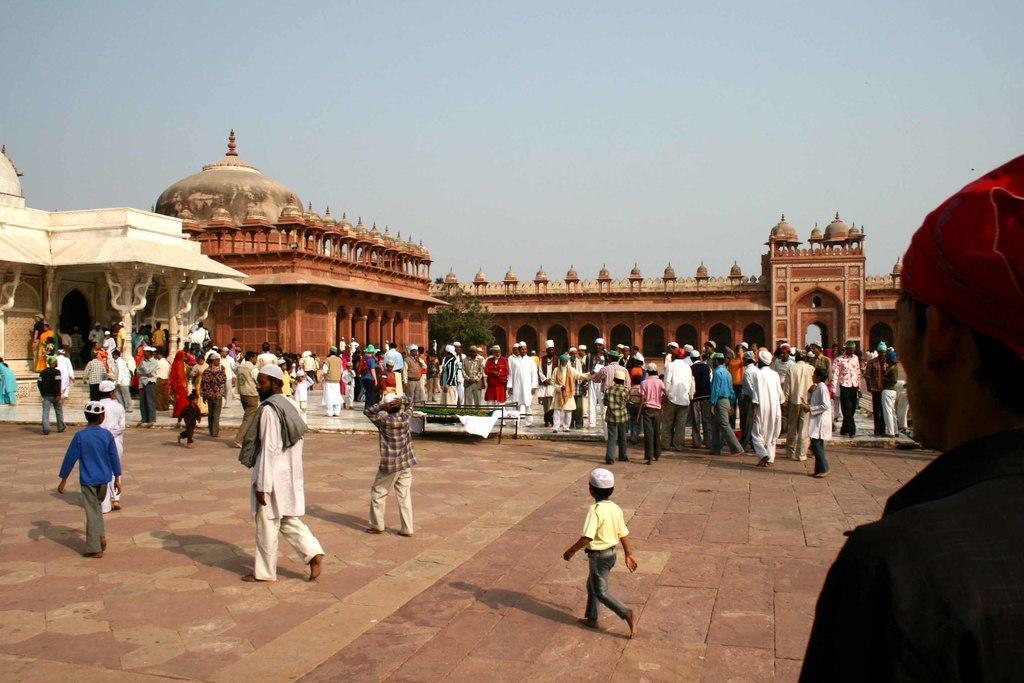Please provide a concise description of this image. In this image I see the path on which there are number of people and I see the monuments in the background and I see the leaves over here and I see the clear sky. 